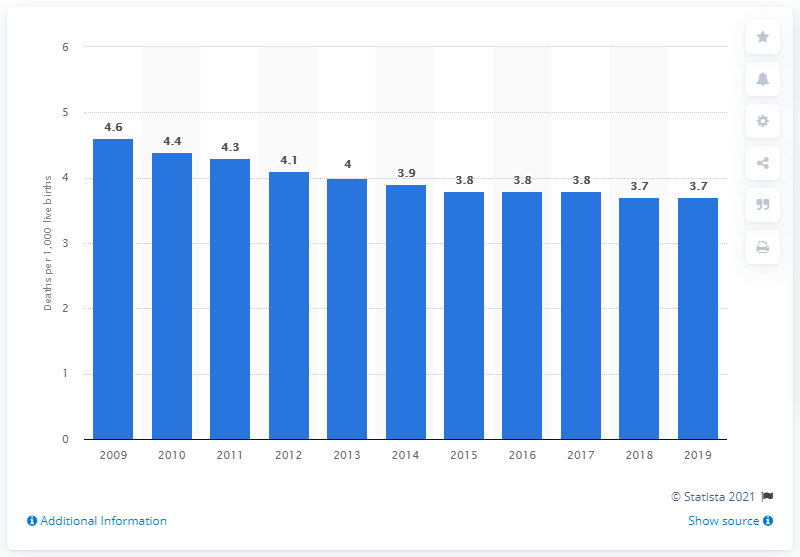Mention a couple of crucial points in this snapshot. In 2019, the infant mortality rate in the UK was 3.7 deaths per 1,000 live births. 